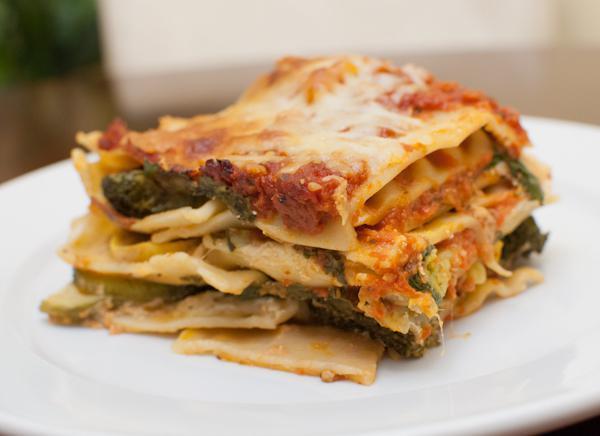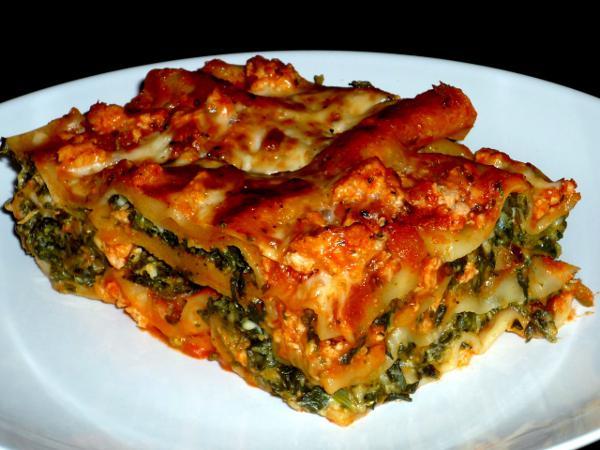The first image is the image on the left, the second image is the image on the right. Examine the images to the left and right. Is the description "There is a green leafy garnish on one of the plates of food." accurate? Answer yes or no. No. 